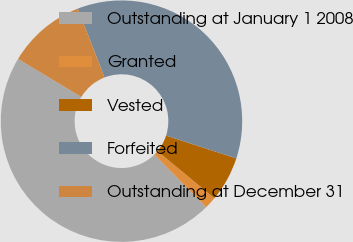Convert chart. <chart><loc_0><loc_0><loc_500><loc_500><pie_chart><fcel>Outstanding at January 1 2008<fcel>Granted<fcel>Vested<fcel>Forfeited<fcel>Outstanding at December 31<nl><fcel>45.99%<fcel>1.6%<fcel>6.04%<fcel>35.88%<fcel>10.48%<nl></chart> 